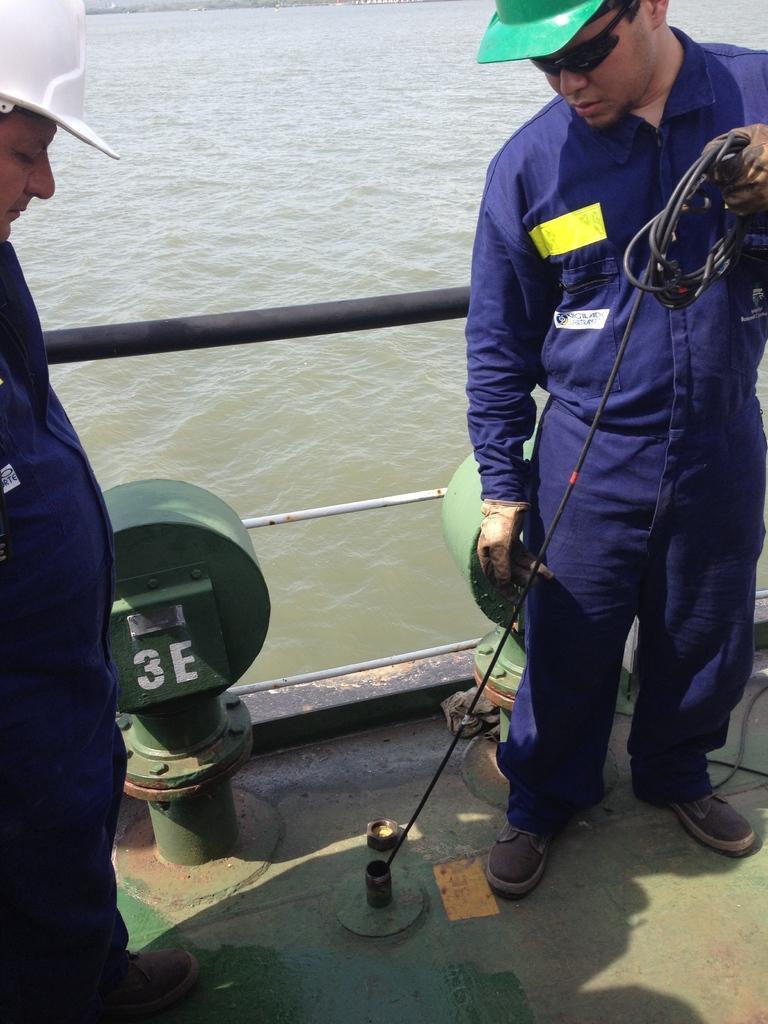Can you describe this image briefly? In this image we can see two persons standing on the boat, one of them is wearing white color hat, and the other one is wearing green color hat, a person is holding a wire, and the boat is on the water. 